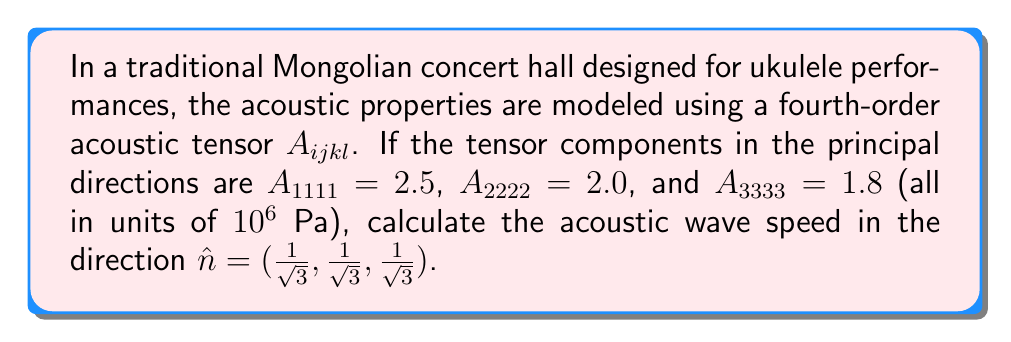Can you answer this question? To solve this problem, we'll follow these steps:

1) The acoustic wave speed $v$ in a given direction $\hat{n}$ is related to the acoustic tensor by:

   $$v^2 = \frac{1}{\rho} A_{ijkl}n_in_jn_kn_l$$

   where $\rho$ is the density of air (approximately 1.2 kg/m³ at room temperature).

2) Given the direction $\hat{n} = (\frac{1}{\sqrt{3}}, \frac{1}{\sqrt{3}}, \frac{1}{\sqrt{3}})$, we need to calculate:

   $$A_{ijkl}n_in_jn_kn_l = A_{1111}n_1^4 + A_{2222}n_2^4 + A_{3333}n_3^4$$

   (assuming the off-diagonal terms are negligible for this simplified model)

3) Substituting the values:

   $$A_{ijkl}n_in_jn_kn_l = 2.5 \cdot (\frac{1}{\sqrt{3}})^4 + 2.0 \cdot (\frac{1}{\sqrt{3}})^4 + 1.8 \cdot (\frac{1}{\sqrt{3}})^4$$

4) Simplifying:

   $$A_{ijkl}n_in_jn_kn_l = (2.5 + 2.0 + 1.8) \cdot \frac{1}{9} = \frac{6.3}{9} = 0.7 \cdot 10^6 \text{ Pa}$$

5) Now we can calculate the wave speed:

   $$v^2 = \frac{1}{\rho} \cdot 0.7 \cdot 10^6 \text{ Pa}$$

   $$v^2 = \frac{0.7 \cdot 10^6}{1.2} \text{ m²/s²}$$

   $$v = \sqrt{\frac{0.7 \cdot 10^6}{1.2}} \text{ m/s}$$

6) Calculating the final result:

   $$v \approx 764.4 \text{ m/s}$$
Answer: 764.4 m/s 